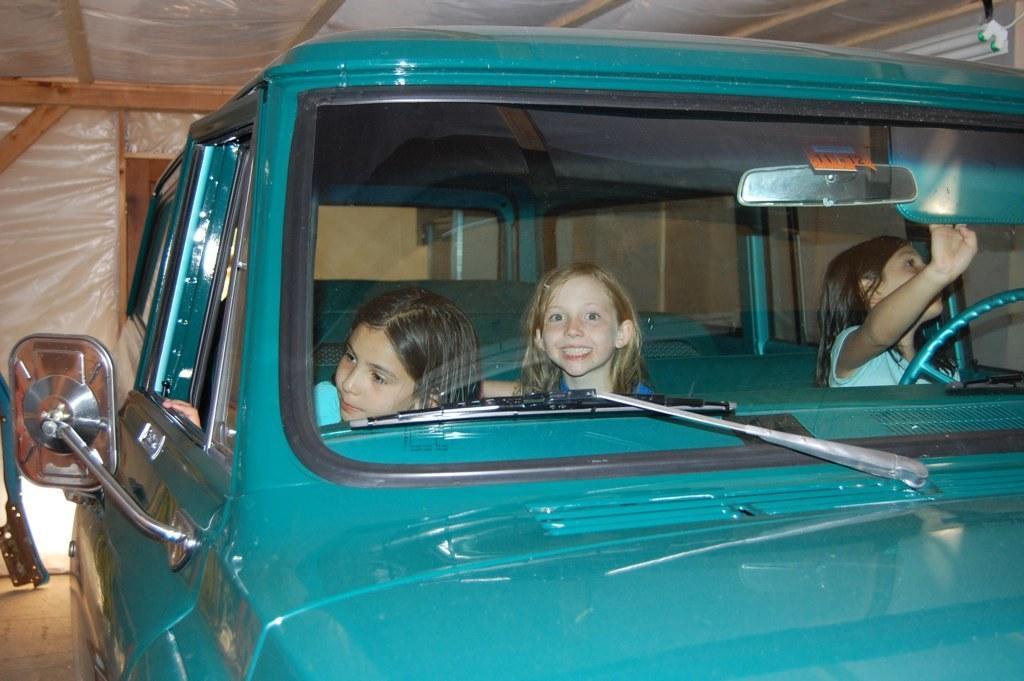Please provide a concise description of this image. In the picture there is a blue color car, inside the car there are three kids three of them are girls ,in the background there is a wooden wall. 